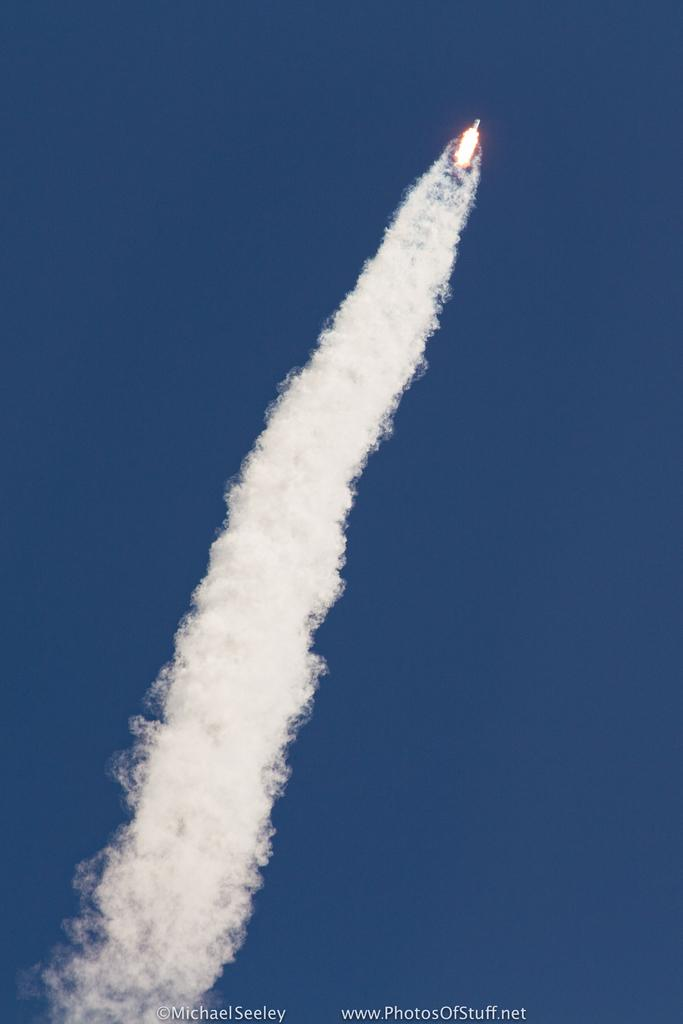What is the main subject of the image? There is a rocket in the image. What is the rocket doing in the image? The rocket is flying in the sky. What can be seen behind the rocket? There is smoke behind the rocket. What type of jar is visible on the rocket in the image? There is no jar present on the rocket in the image. What color is the stocking that the rocket is wearing in the image? Rockets do not wear stockings, and there is no stocking visible in the image. 